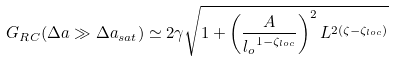<formula> <loc_0><loc_0><loc_500><loc_500>G _ { R C } ( \Delta a \gg { \Delta a } _ { s a t } ) \simeq 2 \gamma \sqrt { 1 + \left ( \frac { A } { { l _ { o } } ^ { 1 - { \zeta } _ { l o c } } } \right ) ^ { 2 } L ^ { 2 ( \zeta - { \zeta } _ { l o c } ) } }</formula> 